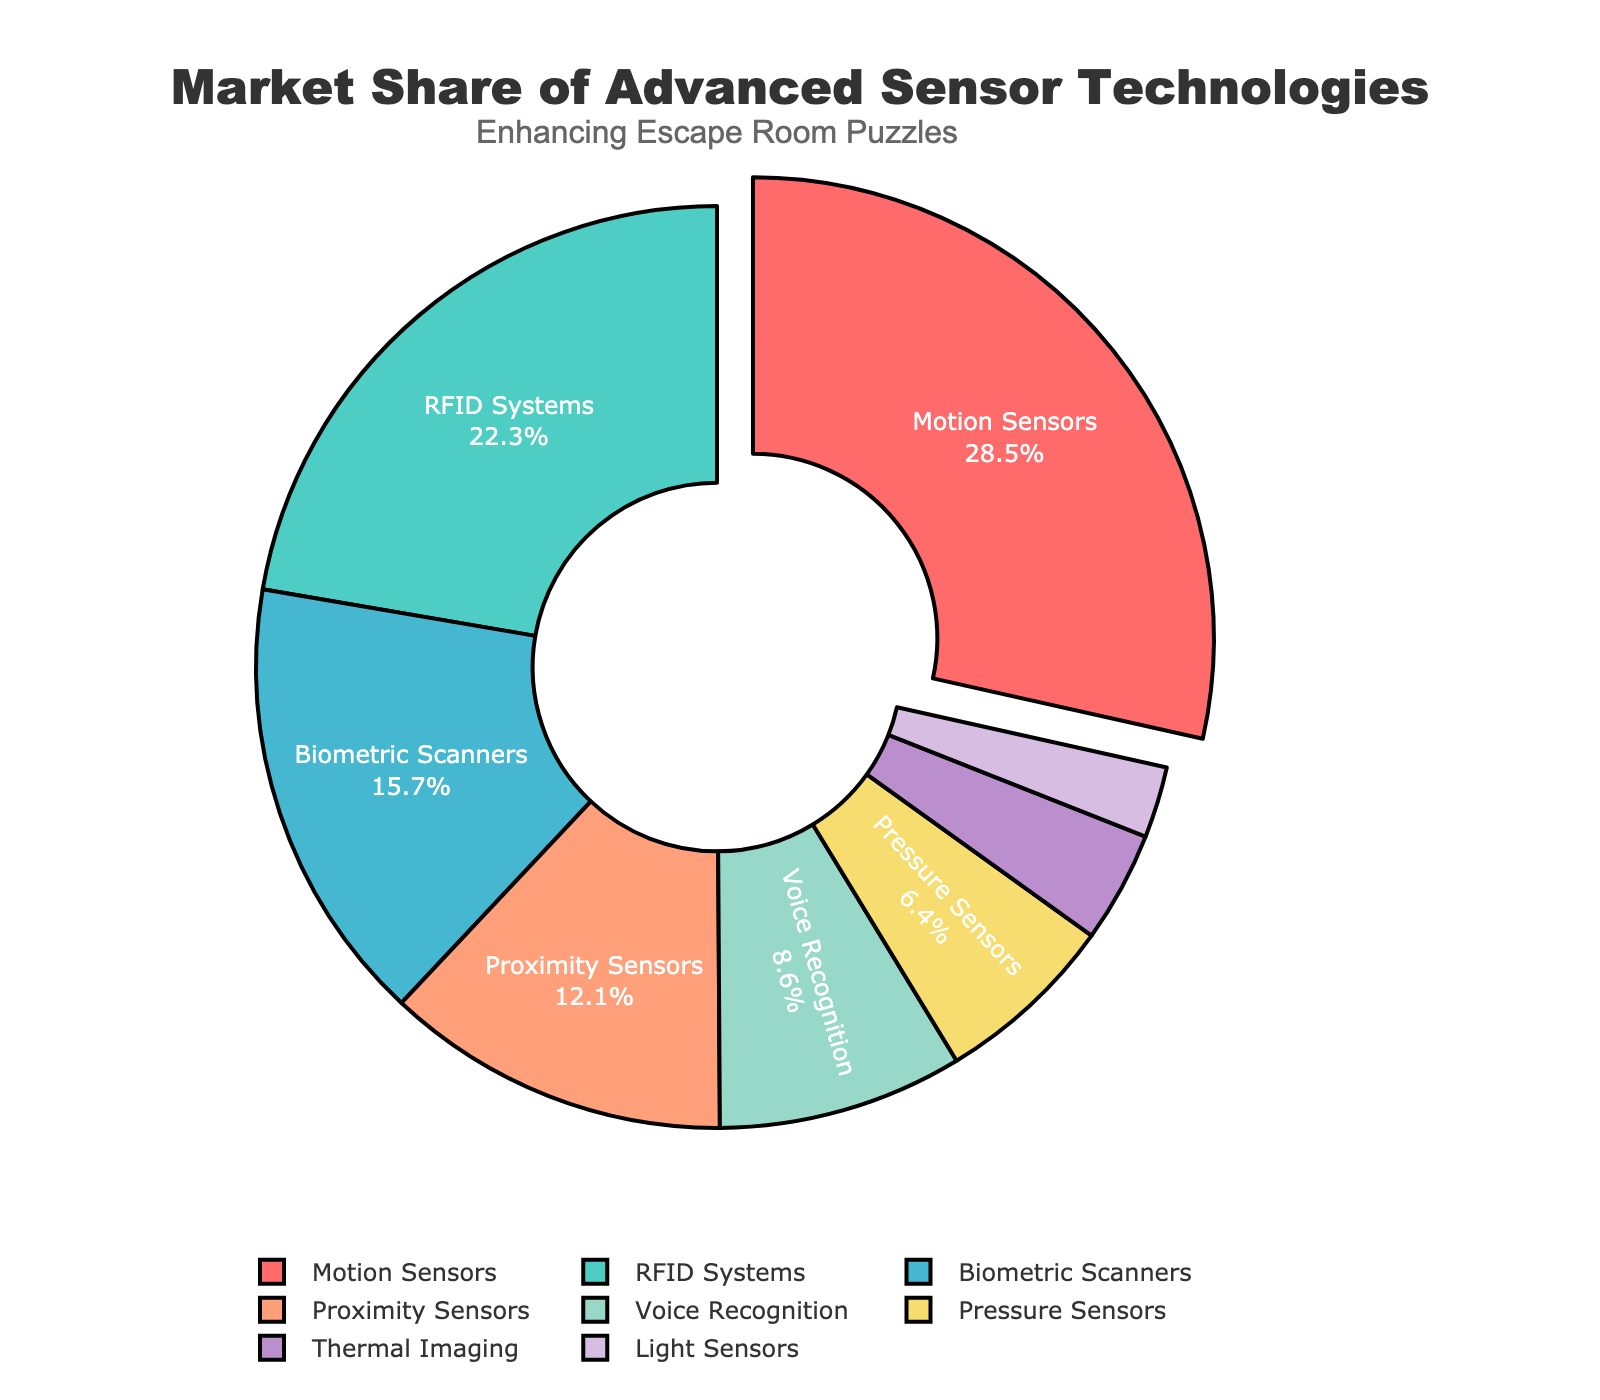What technology has the largest market share? The largest market share is identified by the largest section of the pie chart, which is labeled as Motion Sensors.
Answer: Motion Sensors What is the combined market share of RFID Systems and Biometric Scanners? The market shares of RFID Systems and Biometric Scanners are 22.3% and 15.7% respectively. Adding them together: 22.3 + 15.7 = 38.0%.
Answer: 38.0% Which technology has the smallest market share and what is it? The smallest market share is represented by the smallest section of the pie chart, which is labeled as Light Sensors, with a market share of 2.5%.
Answer: Light Sensors, 2.5% How much greater is the market share of Motion Sensors compared to Proximity Sensors? The market share of Motion Sensors is 28.5%, and that of Proximity Sensors is 12.1%. The difference is calculated as 28.5% - 12.1% = 16.4%.
Answer: 16.4% Which technology has a market share greater than 20%? By inspecting the pie chart, the segments with shares greater than 20% are for Motion Sensors (28.5%) and RFID Systems (22.3%).
Answer: Motion Sensors, RFID Systems What is the total market share of the technologies with a share less than 10%? Technologies with shares less than 10% include Voice Recognition (8.6%), Pressure Sensors (6.4%), Thermal Imaging (3.9%), and Light Sensors (2.5%). Summing them: 8.6 + 6.4 + 3.9 + 2.5 = 21.4%.
Answer: 21.4% What color represents the Biometric Scanners sector in the pie chart? The Biometric Scanners sector is visually represented by a specific color on the pie chart, which is blue.
Answer: Blue Which technology is represented by the sector that is pulled out slightly from the pie chart? The sector that is pulled out slightly is done to emphasize the technology with the largest market share, which is Motion Sensors.
Answer: Motion Sensors Compare the market shares of Pressure Sensors and Thermal Imaging. Which one is larger, and by how much? The market share of Pressure Sensors is 6.4%, and that of Thermal Imaging is 3.9%. The difference is calculated as 6.4% - 3.9% = 2.5%. Thus, Pressure Sensors have a larger market share by 2.5%.
Answer: Pressure Sensors, 2.5% What is the average market share of all the listed technologies? The total market share is 100%, and there are 8 technologies listed. The average market share is calculated as 100% / 8 = 12.5%.
Answer: 12.5% 